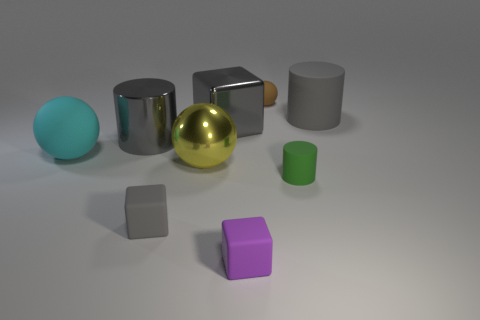Can you describe the material properties of the objects depicted in the image? Certainly! The objects exhibit a variety of material properties. The second object from the left seems to have a matte surface, the one in the middle appears to be shiny and reflective, suggestive of a metallic finish, and the last one on the right has a diffuse, less reflective surface indicating a rubber or plastic material. 